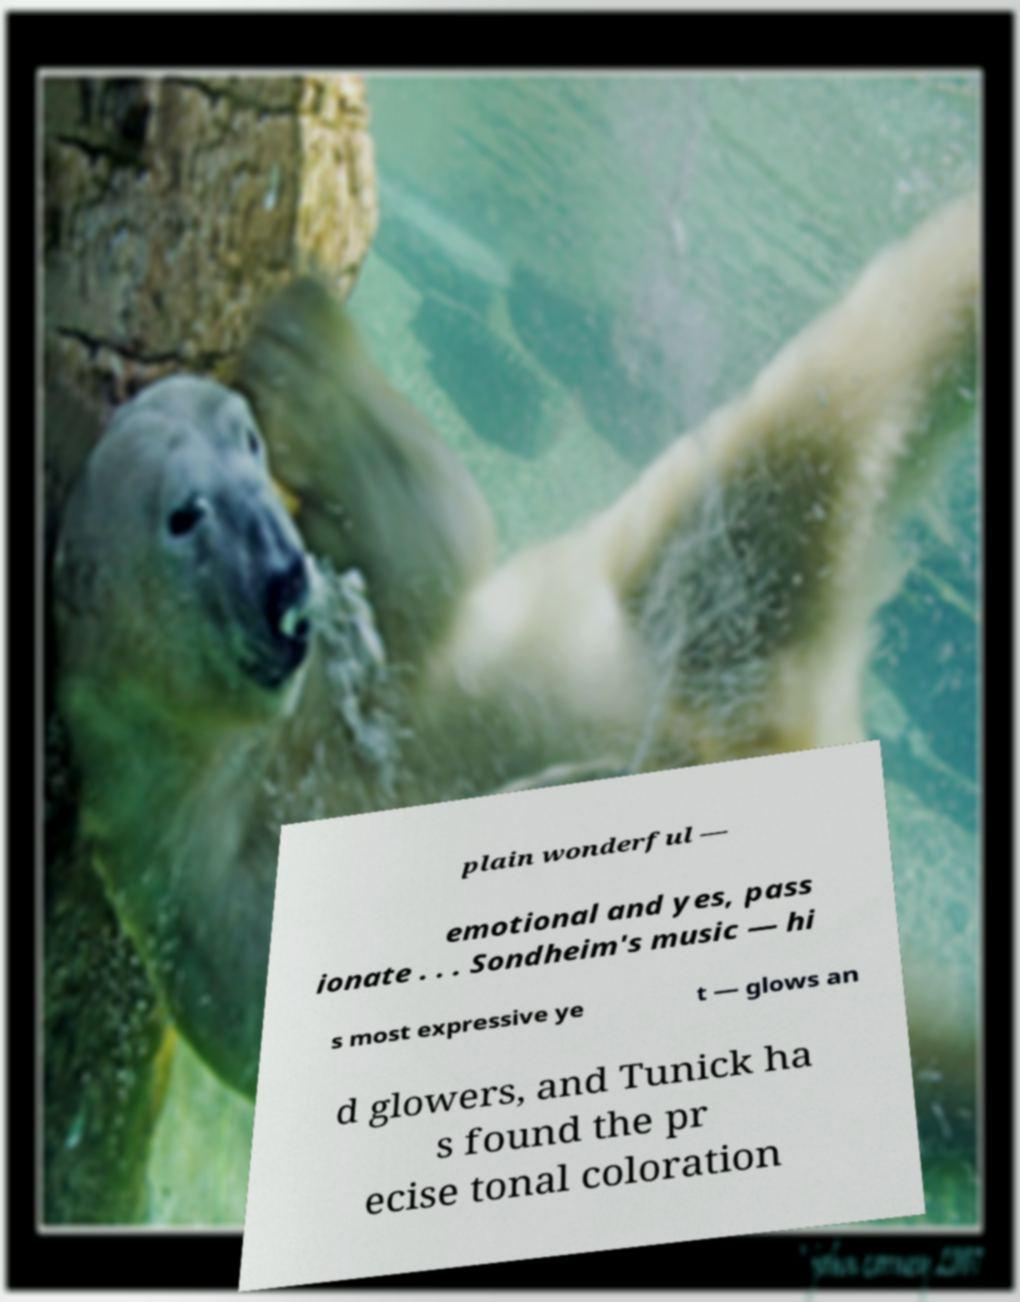Could you assist in decoding the text presented in this image and type it out clearly? plain wonderful — emotional and yes, pass ionate . . . Sondheim's music — hi s most expressive ye t — glows an d glowers, and Tunick ha s found the pr ecise tonal coloration 